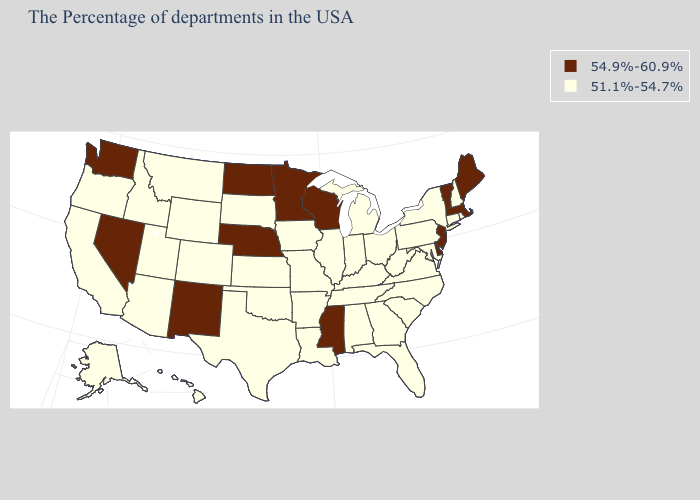What is the highest value in the MidWest ?
Concise answer only. 54.9%-60.9%. Name the states that have a value in the range 54.9%-60.9%?
Be succinct. Maine, Massachusetts, Vermont, New Jersey, Delaware, Wisconsin, Mississippi, Minnesota, Nebraska, North Dakota, New Mexico, Nevada, Washington. What is the value of Georgia?
Be succinct. 51.1%-54.7%. What is the value of Kansas?
Keep it brief. 51.1%-54.7%. Name the states that have a value in the range 54.9%-60.9%?
Give a very brief answer. Maine, Massachusetts, Vermont, New Jersey, Delaware, Wisconsin, Mississippi, Minnesota, Nebraska, North Dakota, New Mexico, Nevada, Washington. What is the value of Maine?
Answer briefly. 54.9%-60.9%. Which states have the lowest value in the USA?
Short answer required. Rhode Island, New Hampshire, Connecticut, New York, Maryland, Pennsylvania, Virginia, North Carolina, South Carolina, West Virginia, Ohio, Florida, Georgia, Michigan, Kentucky, Indiana, Alabama, Tennessee, Illinois, Louisiana, Missouri, Arkansas, Iowa, Kansas, Oklahoma, Texas, South Dakota, Wyoming, Colorado, Utah, Montana, Arizona, Idaho, California, Oregon, Alaska, Hawaii. Does Montana have the same value as New York?
Be succinct. Yes. Name the states that have a value in the range 54.9%-60.9%?
Keep it brief. Maine, Massachusetts, Vermont, New Jersey, Delaware, Wisconsin, Mississippi, Minnesota, Nebraska, North Dakota, New Mexico, Nevada, Washington. What is the value of North Dakota?
Be succinct. 54.9%-60.9%. How many symbols are there in the legend?
Give a very brief answer. 2. What is the highest value in the USA?
Keep it brief. 54.9%-60.9%. Name the states that have a value in the range 54.9%-60.9%?
Short answer required. Maine, Massachusetts, Vermont, New Jersey, Delaware, Wisconsin, Mississippi, Minnesota, Nebraska, North Dakota, New Mexico, Nevada, Washington. Name the states that have a value in the range 54.9%-60.9%?
Answer briefly. Maine, Massachusetts, Vermont, New Jersey, Delaware, Wisconsin, Mississippi, Minnesota, Nebraska, North Dakota, New Mexico, Nevada, Washington. Does Ohio have the highest value in the USA?
Keep it brief. No. 